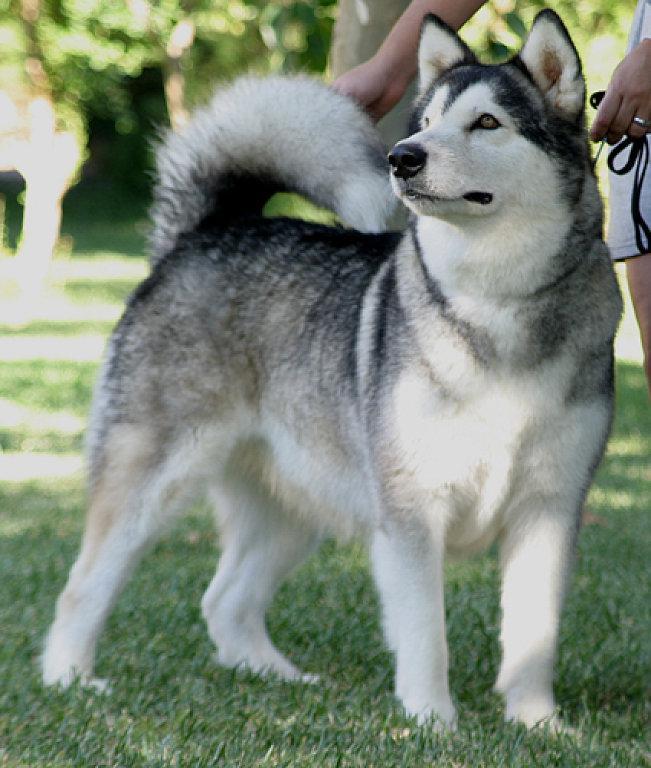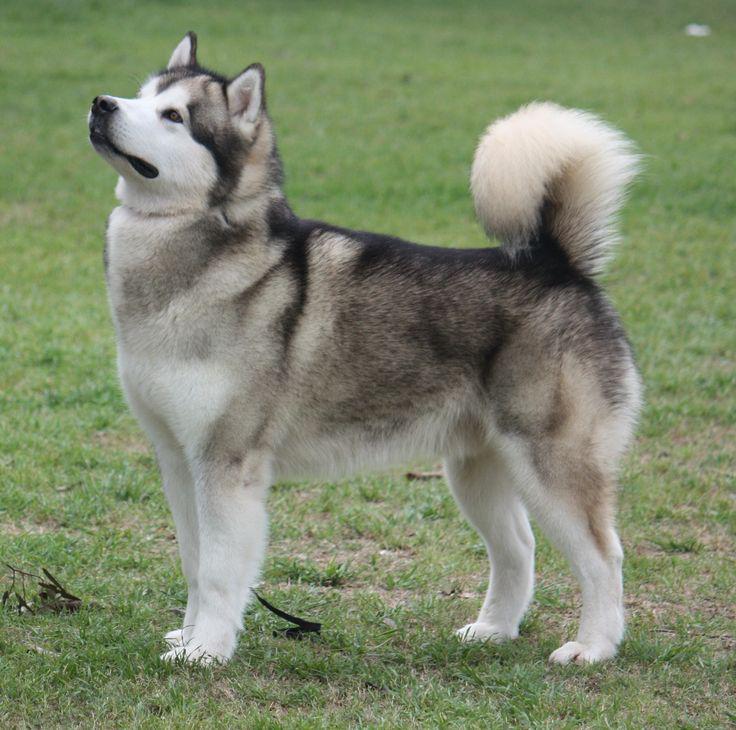The first image is the image on the left, the second image is the image on the right. Examine the images to the left and right. Is the description "There are exactly two dogs with their mouths open." accurate? Answer yes or no. No. The first image is the image on the left, the second image is the image on the right. For the images shown, is this caption "Each image shows one dog standing still with its body mostly in profile, and at least one dog has an upturned curled tail." true? Answer yes or no. Yes. 